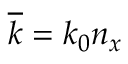<formula> <loc_0><loc_0><loc_500><loc_500>\overline { k } = k _ { 0 } n _ { x }</formula> 